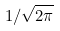<formula> <loc_0><loc_0><loc_500><loc_500>1 / \sqrt { 2 \pi }</formula> 